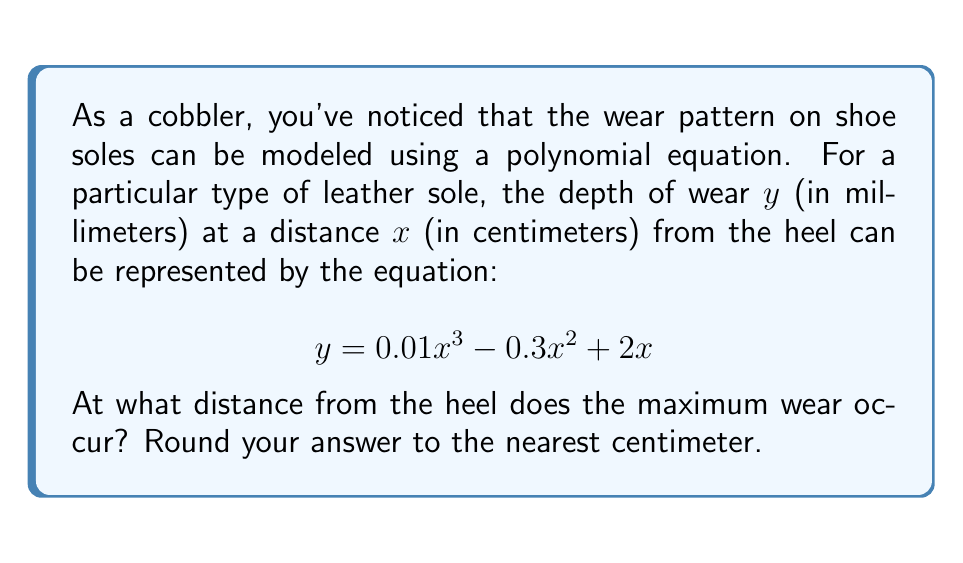Can you solve this math problem? To find the point of maximum wear, we need to follow these steps:

1) The maximum point occurs where the derivative of the function is zero. Let's find the derivative:

   $$ \frac{dy}{dx} = 0.03x^2 - 0.6x + 2 $$

2) Set the derivative equal to zero:

   $$ 0.03x^2 - 0.6x + 2 = 0 $$

3) This is a quadratic equation. We can solve it using the quadratic formula:
   $$ x = \frac{-b \pm \sqrt{b^2 - 4ac}}{2a} $$
   where $a = 0.03$, $b = -0.6$, and $c = 2$

4) Substituting these values:

   $$ x = \frac{0.6 \pm \sqrt{(-0.6)^2 - 4(0.03)(2)}}{2(0.03)} $$

5) Simplifying:

   $$ x = \frac{0.6 \pm \sqrt{0.36 - 0.24}}{0.06} = \frac{0.6 \pm \sqrt{0.12}}{0.06} $$

6) Calculating:

   $$ x \approx 13.33 \text{ or } 6.67 $$

7) Since we're looking for the maximum wear, we need to check which of these points gives the larger y-value in the original equation.

8) Rounding to the nearest centimeter, our options are 13 cm or 7 cm.

Therefore, the maximum wear occurs approximately 13 cm from the heel.
Answer: 13 cm 